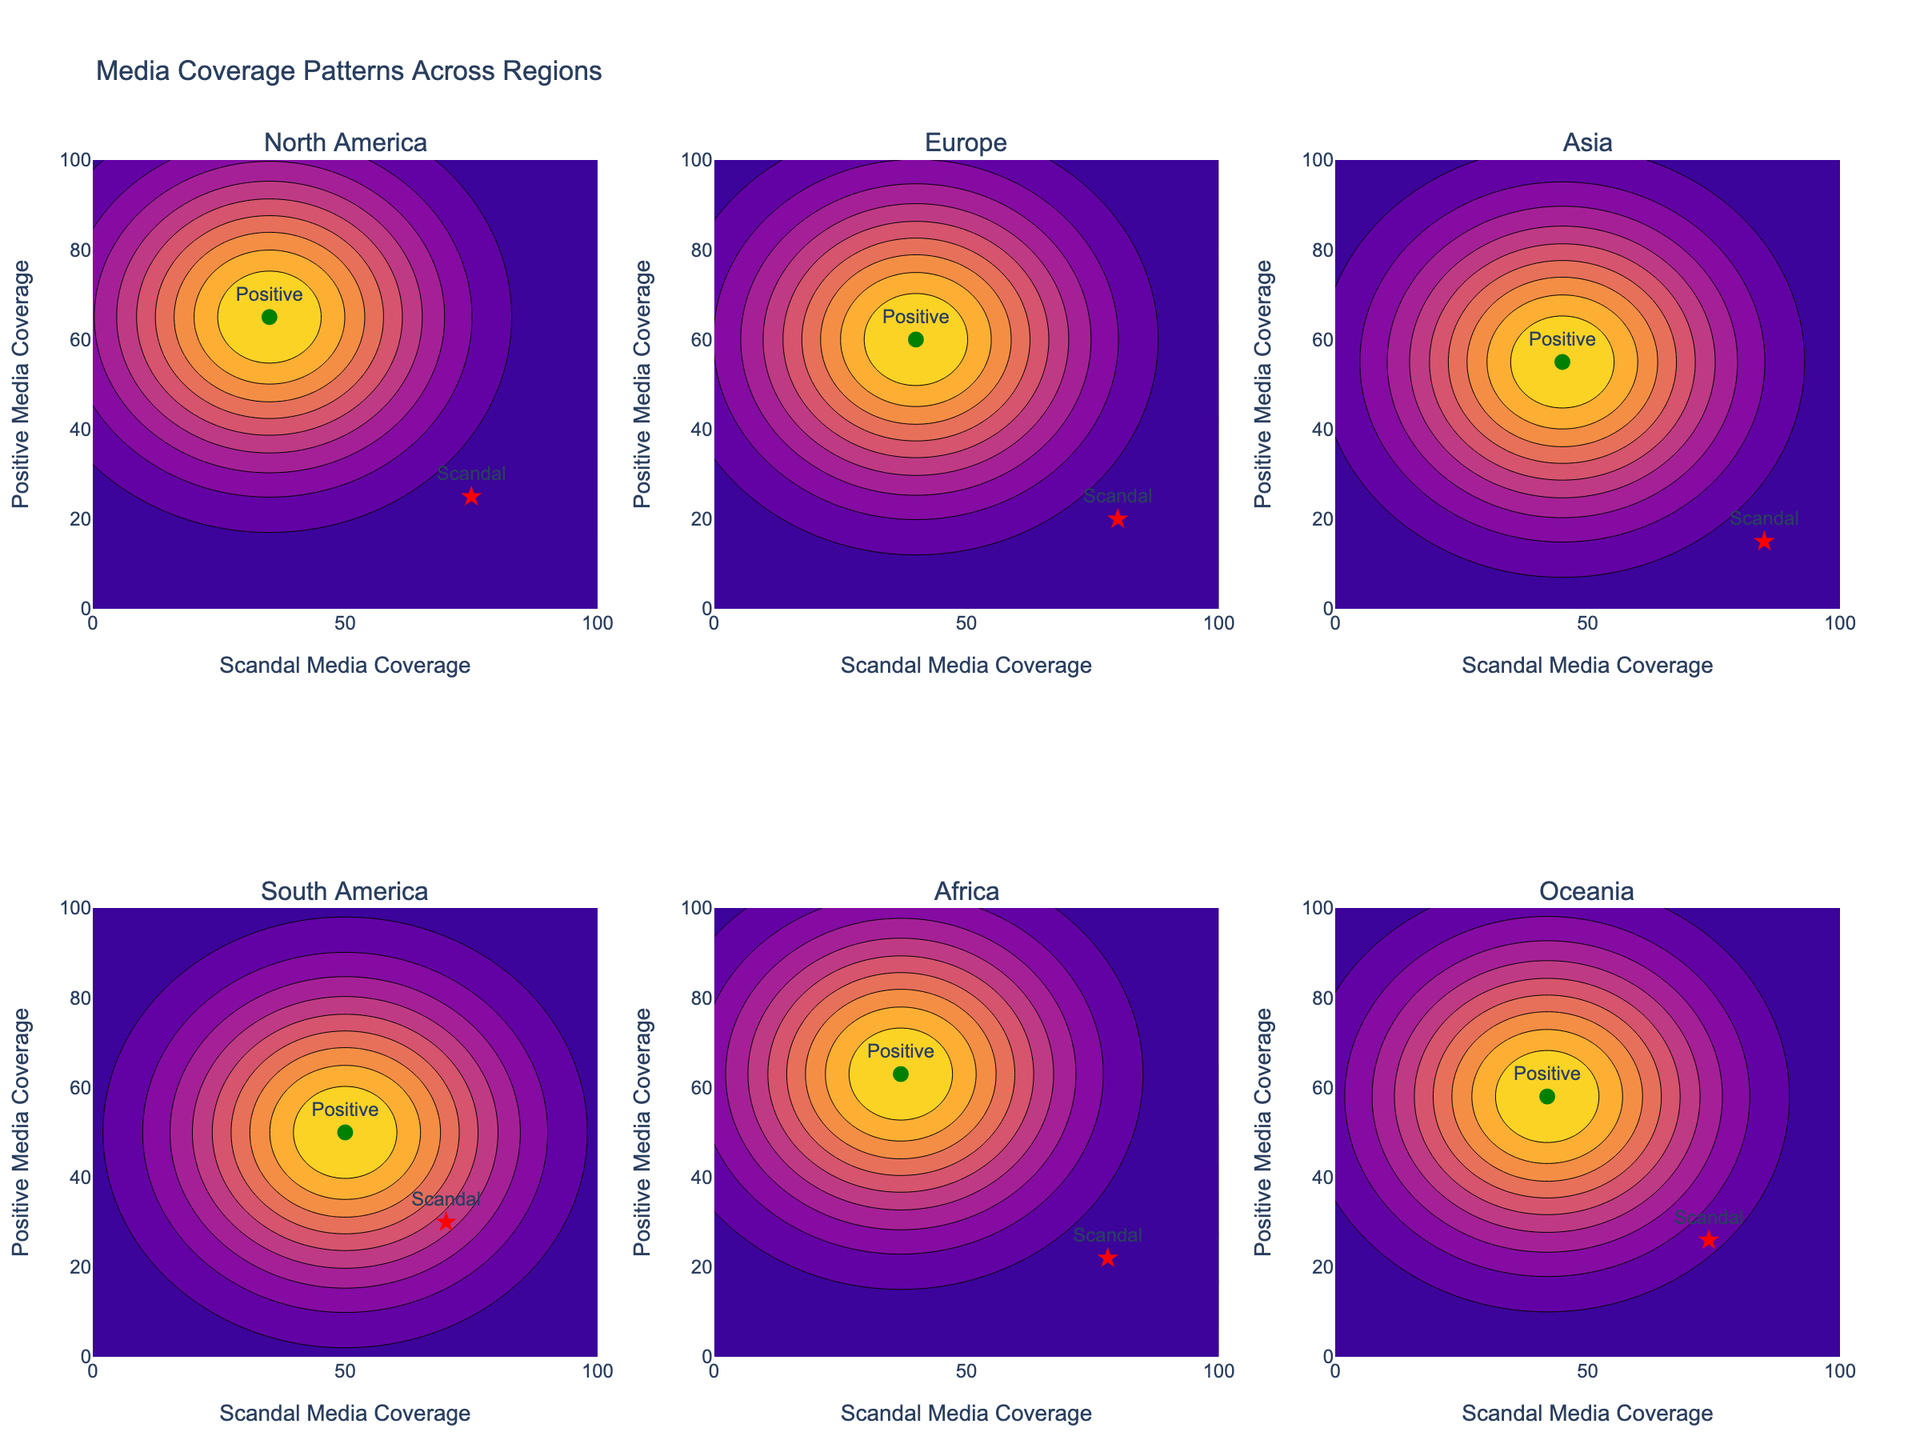What is the title of the figure? The title of the figure is mentioned at the top of the plot. It clearly states what the figure is about.
Answer: Media Coverage Patterns Across Regions How many regions are compared in the figure? The subplot titles indicate the number of different regions. By counting these titles, we notice six regions.
Answer: 6 What are the x- and y-axes representing? Each subplot's x-axis and y-axis are labeled. The x-axis represents Scandal Media Coverage, and the y-axis represents Positive Media Coverage.
Answer: Scandal Media Coverage and Positive Media Coverage Which region has the highest positive media coverage for positive political news? By examining the position marked with "Positive" in each subplot and comparing their y-values, we see that South America shows the highest y-value for positive political news.
Answer: South America In North America, what is the intensity pattern observed for scandal media coverage? By looking at the North America subplot, we focus on the contour with green shades representing scandal coverage. It forms a high-intensity area around the point (75, 25).
Answer: High intensity around (75, 25) Compare the media coverage of scandals between Europe and Asia. Which region shows higher scandal media coverage? Examine the scandal coverage markers in the subplots for Europe and Asia. We see Europe has a marker at (80, 20) and Asia at (85, 15). Thus, Asia has higher scandal media coverage.
Answer: Asia Which region shows an equal balance between scandal and positive media coverage? Look for a region where the labels for scandal and positive media coverage have the same coordinates. South America has markers at (70, 30) for scandal and (50, 50) for positive coverage, where the positive point lies on the balance line.
Answer: South America Which region has the most significant spread between scandal and positive media coverage? Calculate the difference between the markers for scandal and positive in each subplot. Asia shows the most significant spread with scandal at (85, 15) and positive at (45, 55), yielding a difference of 40 in both directions.
Answer: Asia 